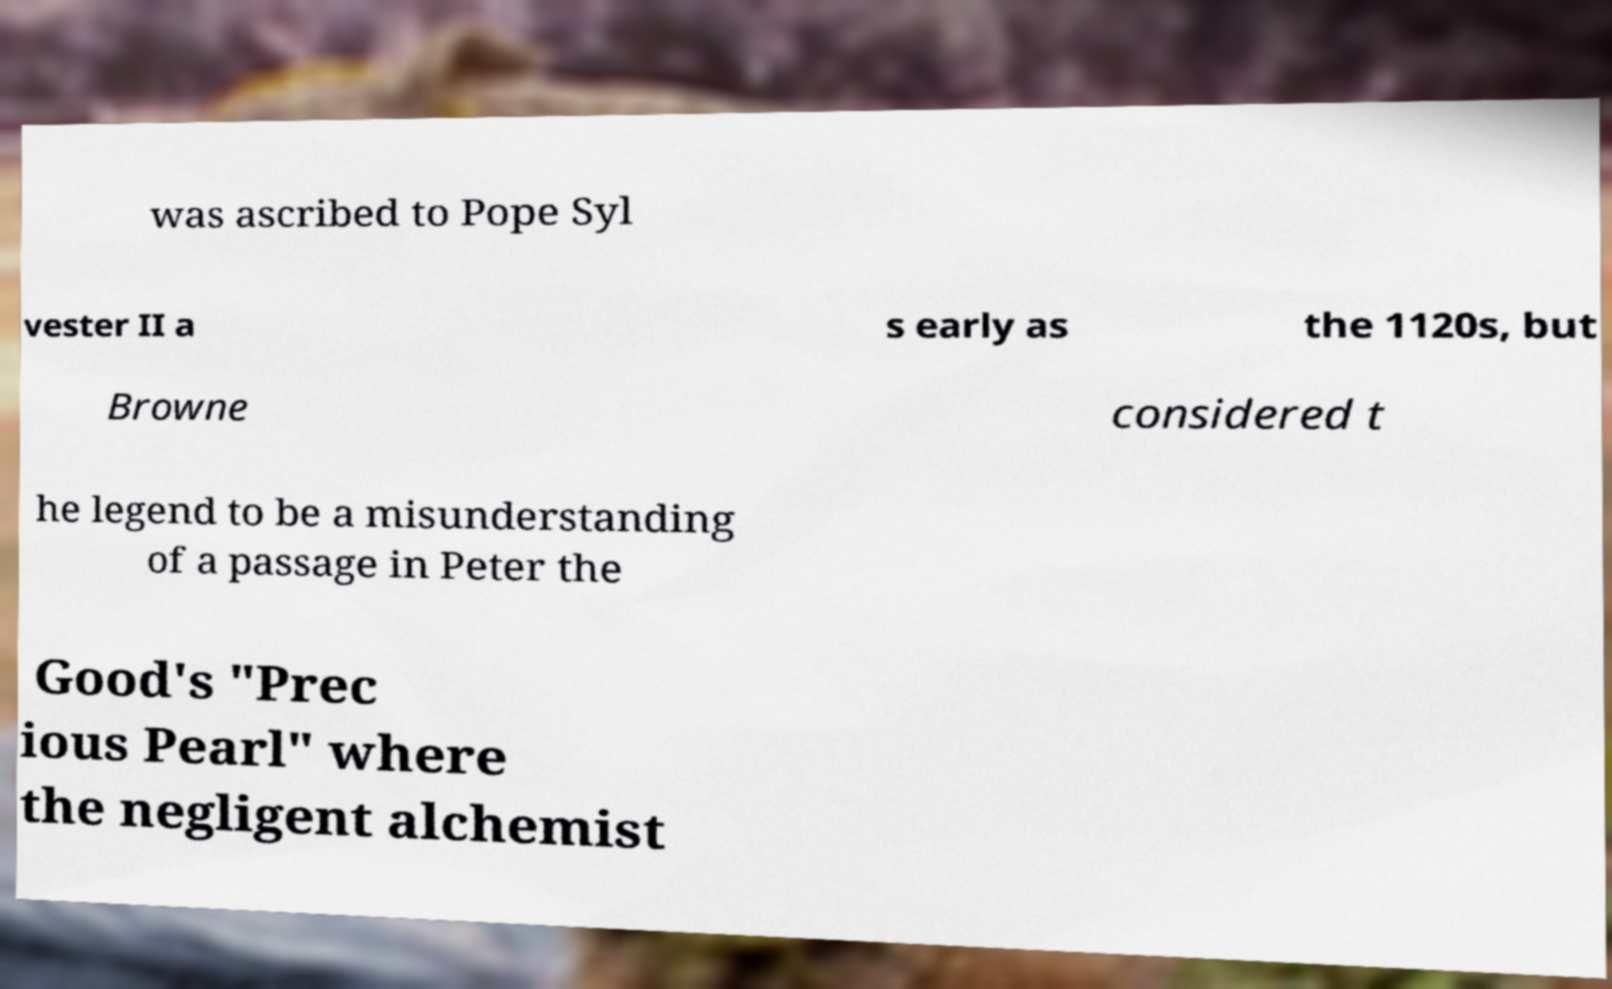There's text embedded in this image that I need extracted. Can you transcribe it verbatim? was ascribed to Pope Syl vester II a s early as the 1120s, but Browne considered t he legend to be a misunderstanding of a passage in Peter the Good's "Prec ious Pearl" where the negligent alchemist 